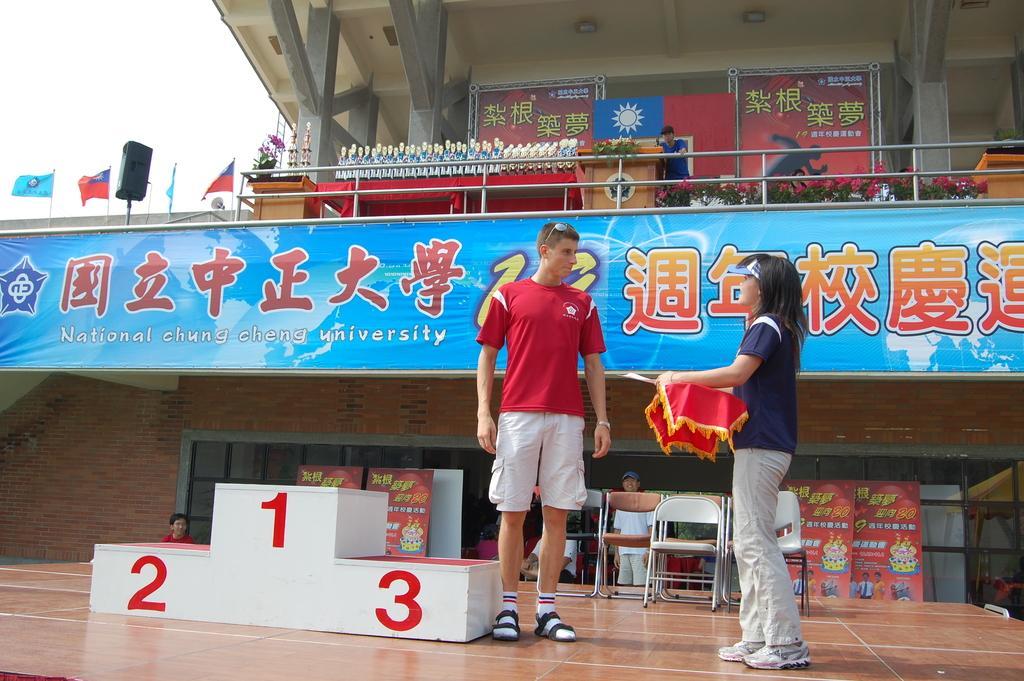In one or two sentences, can you explain what this image depicts? In this picture I can see a man and a woman who are standing in front and I see that the woman is holding a red color thing and on the left side of this picture I can see a white color thing on which there are numbers. In the background I can see few people, chairs, boards on which there is something written and I can see the plants and flowers. I can also see few flags and I see other things. On the top of this picture I can see the pillars and I see that it is white color on the left top corner of this picture. 